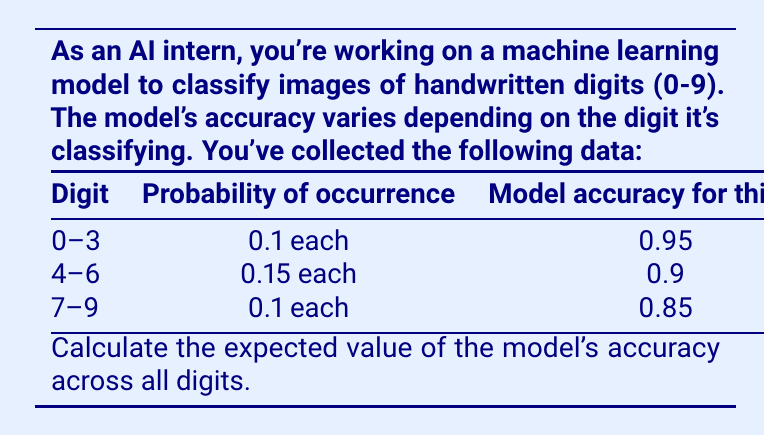Can you answer this question? To calculate the expected value of the model's accuracy, we need to follow these steps:

1) First, recall the formula for expected value:
   $$E(X) = \sum_{i=1}^{n} p_i \cdot x_i$$
   where $p_i$ is the probability of each outcome and $x_i$ is the value of each outcome.

2) In this case, we have three groups of digits with different probabilities and accuracies:
   - Digits 0-3: probability 0.1 each, accuracy 0.95
   - Digits 4-6: probability 0.15 each, accuracy 0.9
   - Digits 7-9: probability 0.1 each, accuracy 0.85

3) Let's calculate the contribution of each group to the expected value:
   - Digits 0-3: $4 \cdot (0.1 \cdot 0.95) = 0.38$
   - Digits 4-6: $3 \cdot (0.15 \cdot 0.9) = 0.405$
   - Digits 7-9: $3 \cdot (0.1 \cdot 0.85) = 0.255$

4) Now, we sum these contributions:
   $$E(\text{accuracy}) = 0.38 + 0.405 + 0.255 = 1.04$$

5) To verify, we can check that the probabilities sum to 1:
   $$(4 \cdot 0.1) + (3 \cdot 0.15) + (3 \cdot 0.1) = 0.4 + 0.45 + 0.3 = 1.15$$

Therefore, the expected value of the model's accuracy is 0.904 or 90.4%.
Answer: 0.904 